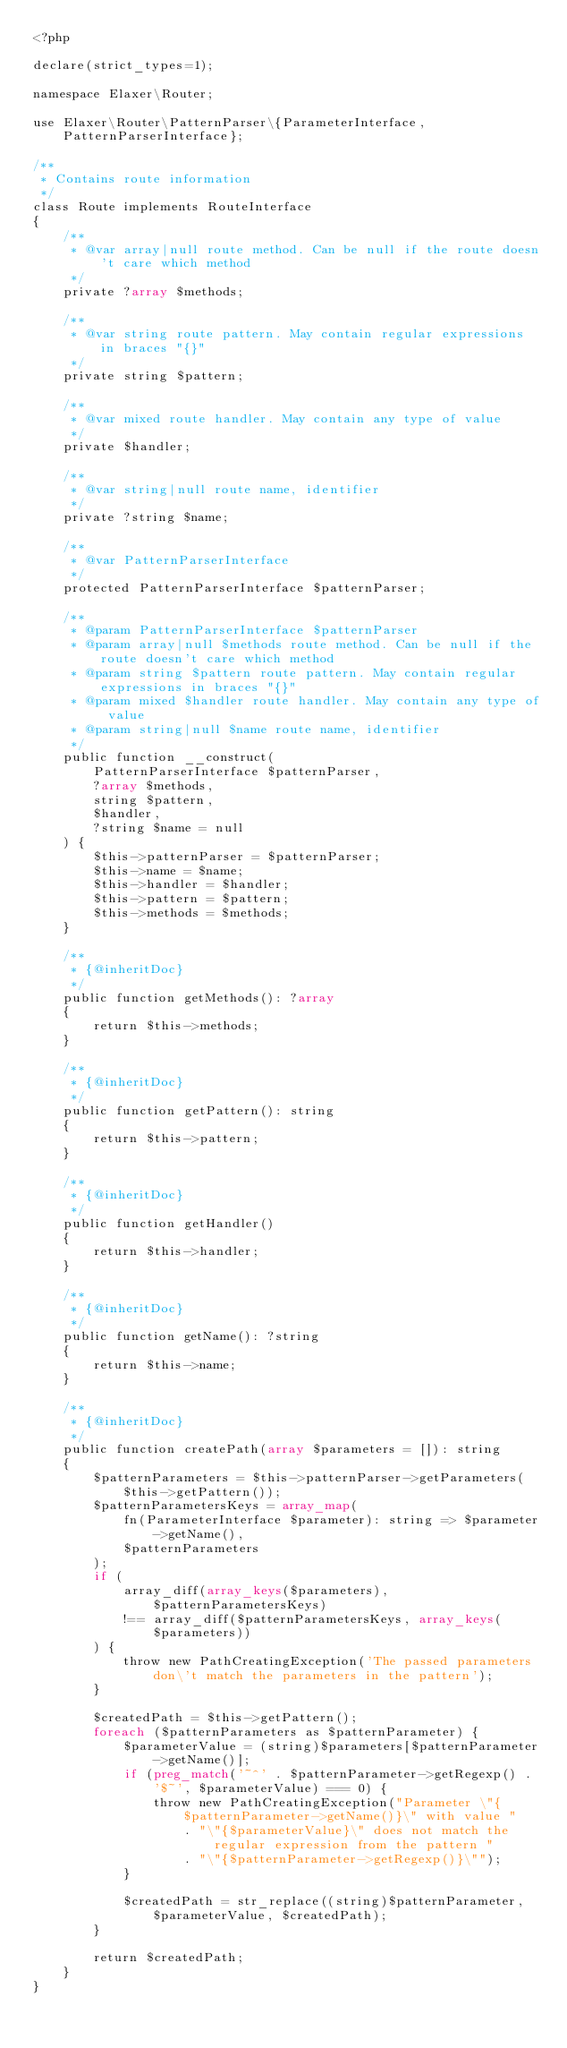<code> <loc_0><loc_0><loc_500><loc_500><_PHP_><?php

declare(strict_types=1);

namespace Elaxer\Router;

use Elaxer\Router\PatternParser\{ParameterInterface, PatternParserInterface};

/**
 * Contains route information
 */
class Route implements RouteInterface
{
    /**
     * @var array|null route method. Can be null if the route doesn't care which method
     */
    private ?array $methods;

    /**
     * @var string route pattern. May contain regular expressions in braces "{}"
     */
    private string $pattern;

    /**
     * @var mixed route handler. May contain any type of value
     */
    private $handler;

    /**
     * @var string|null route name, identifier
     */
    private ?string $name;

    /**
     * @var PatternParserInterface
     */
    protected PatternParserInterface $patternParser;

    /**
     * @param PatternParserInterface $patternParser
     * @param array|null $methods route method. Can be null if the route doesn't care which method
     * @param string $pattern route pattern. May contain regular expressions in braces "{}"
     * @param mixed $handler route handler. May contain any type of value
     * @param string|null $name route name, identifier
     */
    public function __construct(
        PatternParserInterface $patternParser,
        ?array $methods,
        string $pattern,
        $handler,
        ?string $name = null
    ) {
        $this->patternParser = $patternParser;
        $this->name = $name;
        $this->handler = $handler;
        $this->pattern = $pattern;
        $this->methods = $methods;
    }

    /**
     * {@inheritDoc}
     */
    public function getMethods(): ?array
    {
        return $this->methods;
    }

    /**
     * {@inheritDoc}
     */
    public function getPattern(): string
    {
        return $this->pattern;
    }

    /**
     * {@inheritDoc}
     */
    public function getHandler()
    {
        return $this->handler;
    }

    /**
     * {@inheritDoc}
     */
    public function getName(): ?string
    {
        return $this->name;
    }

    /**
     * {@inheritDoc}
     */
    public function createPath(array $parameters = []): string
    {
        $patternParameters = $this->patternParser->getParameters($this->getPattern());
        $patternParametersKeys = array_map(
            fn(ParameterInterface $parameter): string => $parameter->getName(),
            $patternParameters
        );
        if (
            array_diff(array_keys($parameters), $patternParametersKeys)
            !== array_diff($patternParametersKeys, array_keys($parameters))
        ) {
            throw new PathCreatingException('The passed parameters don\'t match the parameters in the pattern');
        }

        $createdPath = $this->getPattern();
        foreach ($patternParameters as $patternParameter) {
            $parameterValue = (string)$parameters[$patternParameter->getName()];
            if (preg_match('~^' . $patternParameter->getRegexp() . '$~', $parameterValue) === 0) {
                throw new PathCreatingException("Parameter \"{$patternParameter->getName()}\" with value "
                    . "\"{$parameterValue}\" does not match the regular expression from the pattern "
                    . "\"{$patternParameter->getRegexp()}\"");
            }

            $createdPath = str_replace((string)$patternParameter, $parameterValue, $createdPath);
        }

        return $createdPath;
    }
}
</code> 